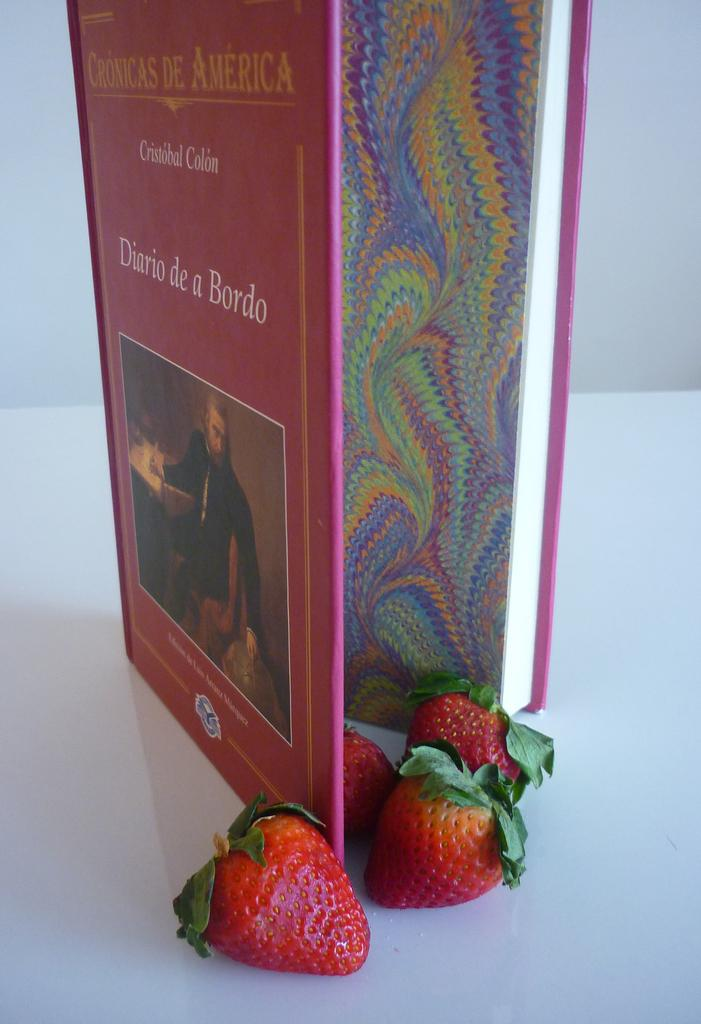What object can be seen in the image that is typically used for reading or learning? There is a book in the image. What type of fruit is present in the image? Strawberries are present in the image. What color is the surface the book and strawberries are on? The surface the book and strawberries are on is white. What can be seen in the background of the image? There is a wall in the background of the image. What type of pan is being used to cook the strawberries in the image? There is no pan or cooking activity present in the image; it only shows a book and strawberries on a white surface with a wall in the background. 